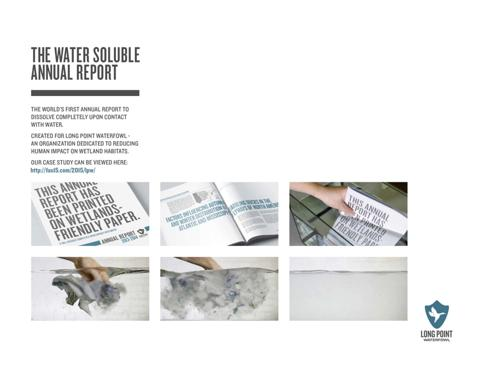What material is used in the manufacturing of this water-soluble paper, and why is it significant? The water-soluble paper used in this annual report is typically made from plant-based materials that quickly dissolve in water without leaving harmful residues. This choice is significant as it underscores the organization's commitment to environmental sustainability, reflecting their focus on wetland preservation. 